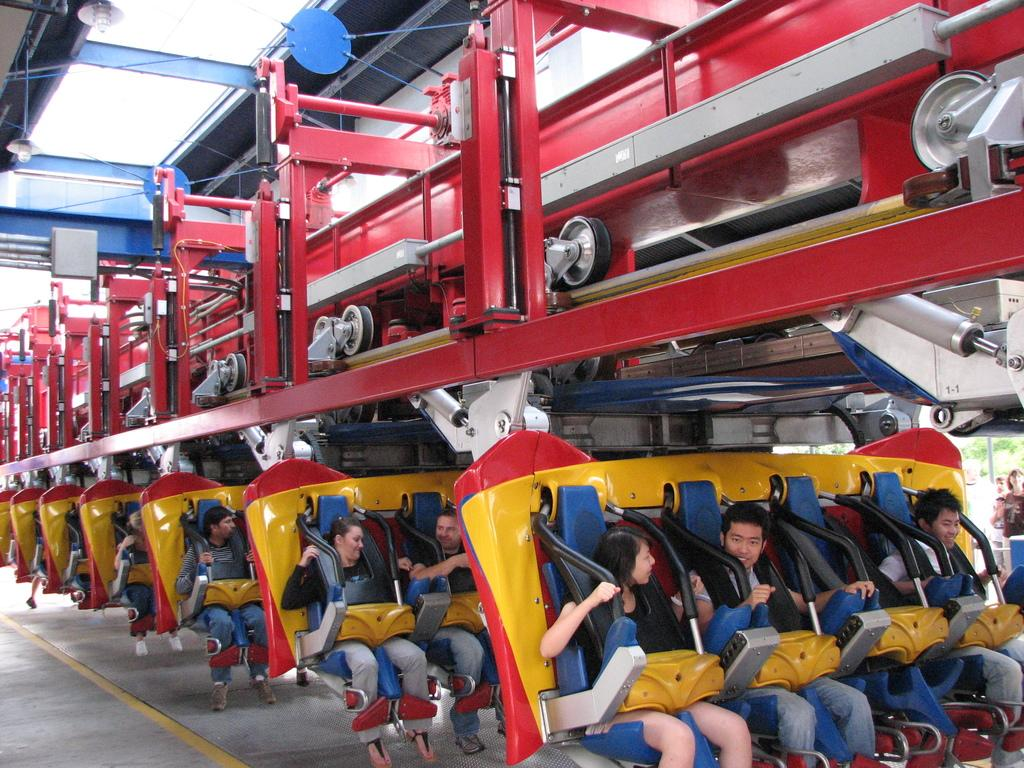Who or what can be seen in the image? There are people in the image. What are the people doing in the image? The people are sitting on a roller coaster ride. What type of list can be seen in the image? There is no list present in the image. 